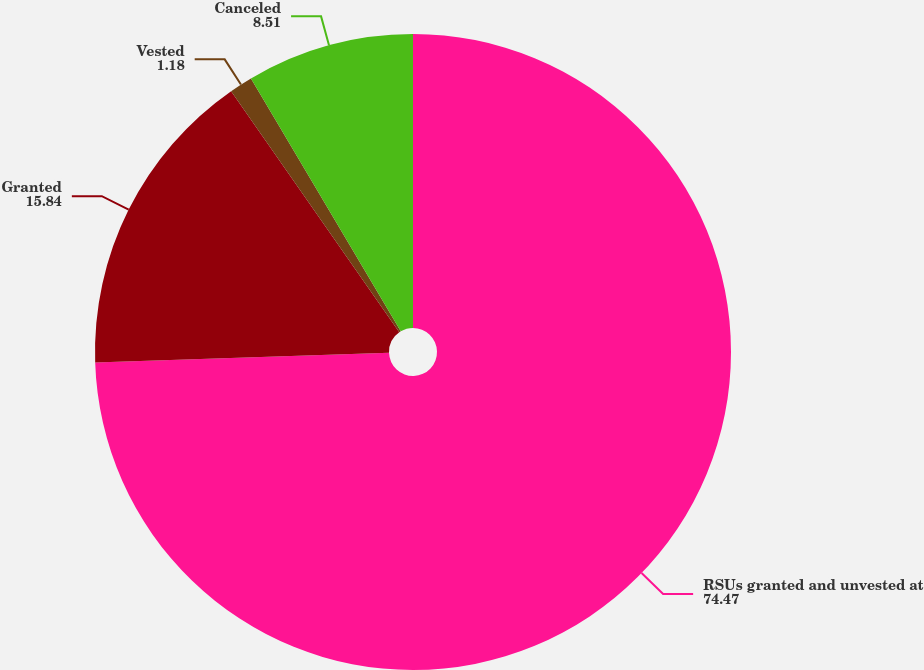Convert chart. <chart><loc_0><loc_0><loc_500><loc_500><pie_chart><fcel>RSUs granted and unvested at<fcel>Granted<fcel>Vested<fcel>Canceled<nl><fcel>74.47%<fcel>15.84%<fcel>1.18%<fcel>8.51%<nl></chart> 